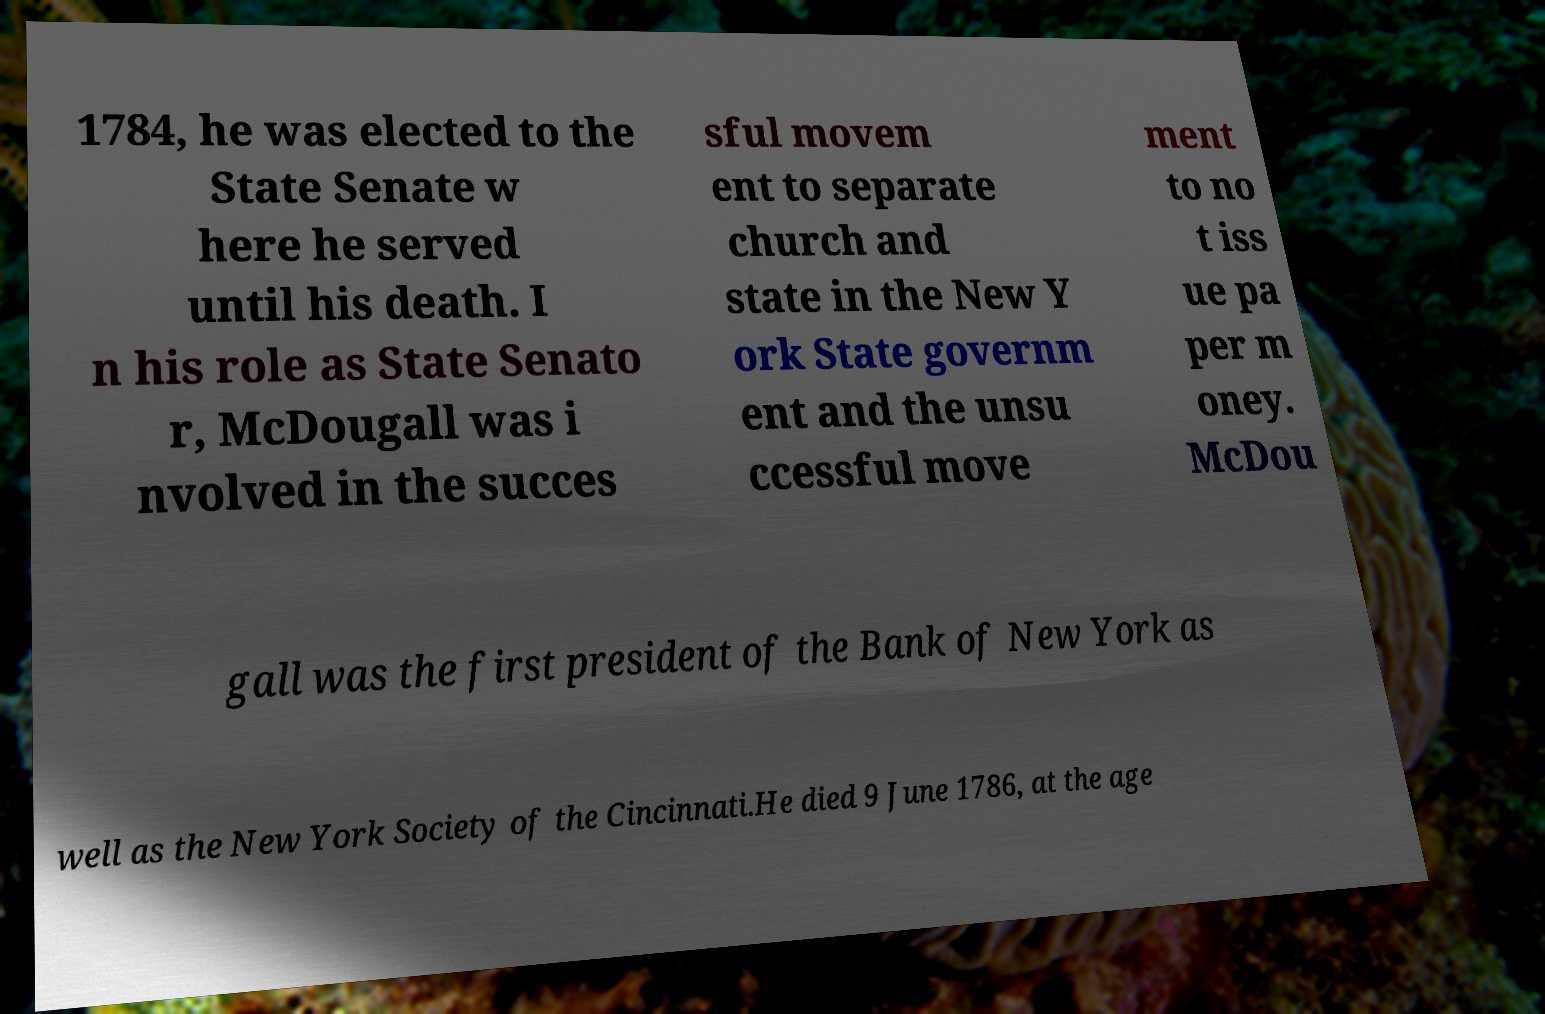Can you read and provide the text displayed in the image?This photo seems to have some interesting text. Can you extract and type it out for me? 1784, he was elected to the State Senate w here he served until his death. I n his role as State Senato r, McDougall was i nvolved in the succes sful movem ent to separate church and state in the New Y ork State governm ent and the unsu ccessful move ment to no t iss ue pa per m oney. McDou gall was the first president of the Bank of New York as well as the New York Society of the Cincinnati.He died 9 June 1786, at the age 